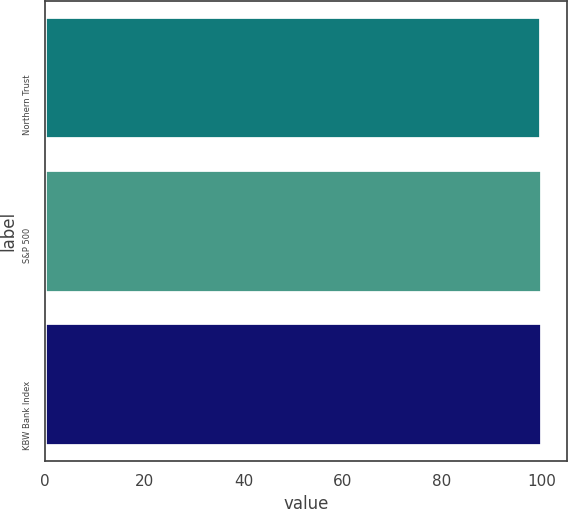Convert chart to OTSL. <chart><loc_0><loc_0><loc_500><loc_500><bar_chart><fcel>Northern Trust<fcel>S&P 500<fcel>KBW Bank Index<nl><fcel>100<fcel>100.1<fcel>100.2<nl></chart> 